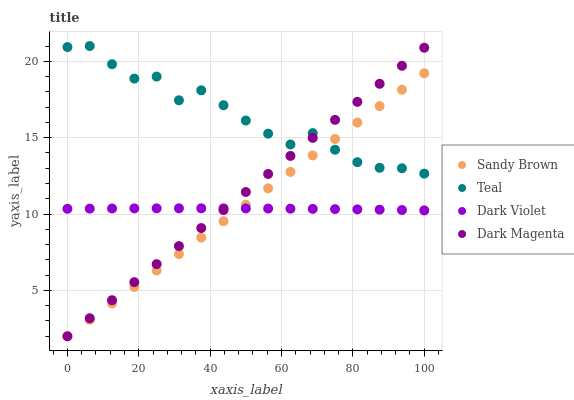Does Dark Violet have the minimum area under the curve?
Answer yes or no. Yes. Does Teal have the maximum area under the curve?
Answer yes or no. Yes. Does Teal have the minimum area under the curve?
Answer yes or no. No. Does Dark Violet have the maximum area under the curve?
Answer yes or no. No. Is Sandy Brown the smoothest?
Answer yes or no. Yes. Is Teal the roughest?
Answer yes or no. Yes. Is Dark Violet the smoothest?
Answer yes or no. No. Is Dark Violet the roughest?
Answer yes or no. No. Does Sandy Brown have the lowest value?
Answer yes or no. Yes. Does Dark Violet have the lowest value?
Answer yes or no. No. Does Teal have the highest value?
Answer yes or no. Yes. Does Dark Violet have the highest value?
Answer yes or no. No. Is Dark Violet less than Teal?
Answer yes or no. Yes. Is Teal greater than Dark Violet?
Answer yes or no. Yes. Does Dark Violet intersect Sandy Brown?
Answer yes or no. Yes. Is Dark Violet less than Sandy Brown?
Answer yes or no. No. Is Dark Violet greater than Sandy Brown?
Answer yes or no. No. Does Dark Violet intersect Teal?
Answer yes or no. No. 